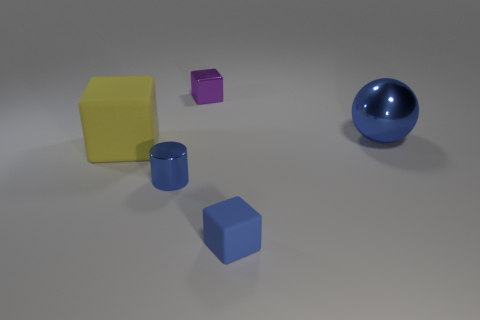What is the size of the yellow matte object that is the same shape as the purple object?
Ensure brevity in your answer.  Large. What number of small purple objects are right of the blue thing behind the large yellow block?
Offer a terse response. 0. Does the blue shiny thing that is left of the purple shiny cube have the same size as the large blue shiny thing?
Ensure brevity in your answer.  No. How many other objects have the same shape as the yellow rubber thing?
Offer a very short reply. 2. The tiny purple metal object is what shape?
Your answer should be very brief. Cube. Is the number of things to the left of the yellow object the same as the number of big gray things?
Your response must be concise. Yes. Is there anything else that is the same material as the yellow cube?
Ensure brevity in your answer.  Yes. Do the large thing that is to the left of the tiny blue cylinder and the purple block have the same material?
Provide a short and direct response. No. Is the number of large blue objects that are on the right side of the large blue thing less than the number of big purple rubber spheres?
Offer a terse response. No. How many metallic things are red cylinders or yellow cubes?
Your answer should be very brief. 0. 